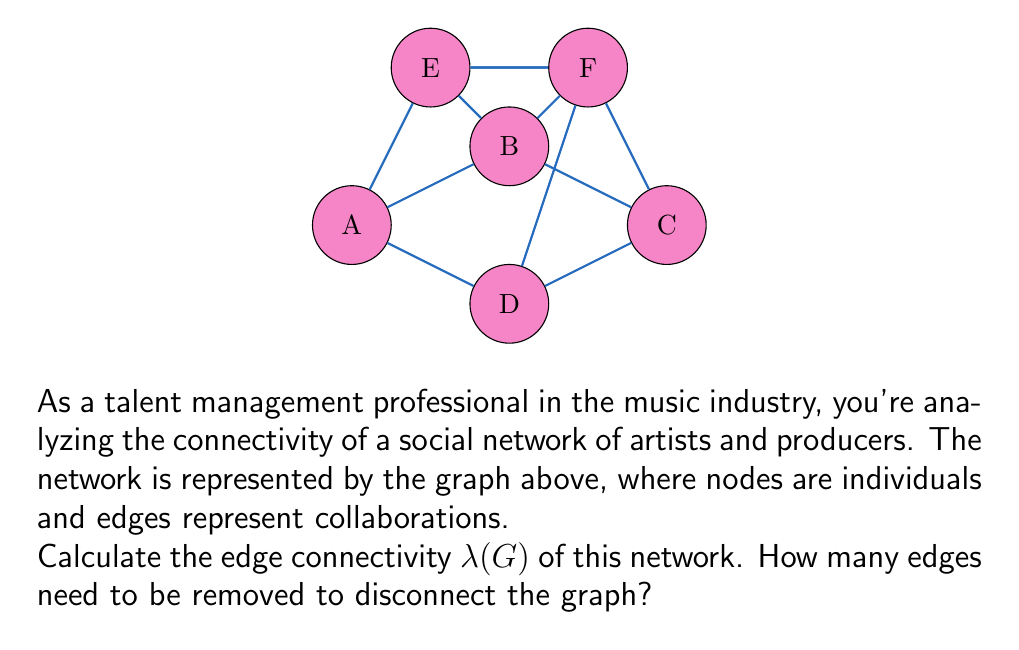Solve this math problem. To find the edge connectivity $\lambda(G)$ of the graph, we need to determine the minimum number of edges that, when removed, will disconnect the graph. Let's approach this step-by-step:

1) First, recall that for any graph G, $\lambda(G) \leq \delta(G)$, where $\delta(G)$ is the minimum degree of any vertex in G.

2) Let's calculate the degree of each vertex:
   A: degree 3
   B: degree 4
   C: degree 4
   D: degree 3
   E: degree 3
   F: degree 4

3) The minimum degree $\delta(G) = 3$, so $\lambda(G) \leq 3$.

4) Now, let's try to find a set of 3 edges that, when removed, will disconnect the graph:
   - If we remove edges AB, AD, and AE, vertex A becomes isolated.

5) We've found a set of 3 edges that disconnects the graph, and we know that $\lambda(G)$ can't be larger than 3.

6) To prove that $\lambda(G) = 3$, we need to show that removing any 2 edges will not disconnect the graph. This can be verified by checking all possible combinations of 2 edge removals, but it's a tedious process and not necessary for this explanation.

Therefore, the edge connectivity $\lambda(G)$ of this network is 3.
Answer: $\lambda(G) = 3$ 